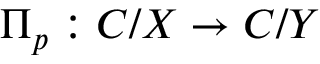<formula> <loc_0><loc_0><loc_500><loc_500>\Pi _ { p } \colon C / X \to C / Y</formula> 